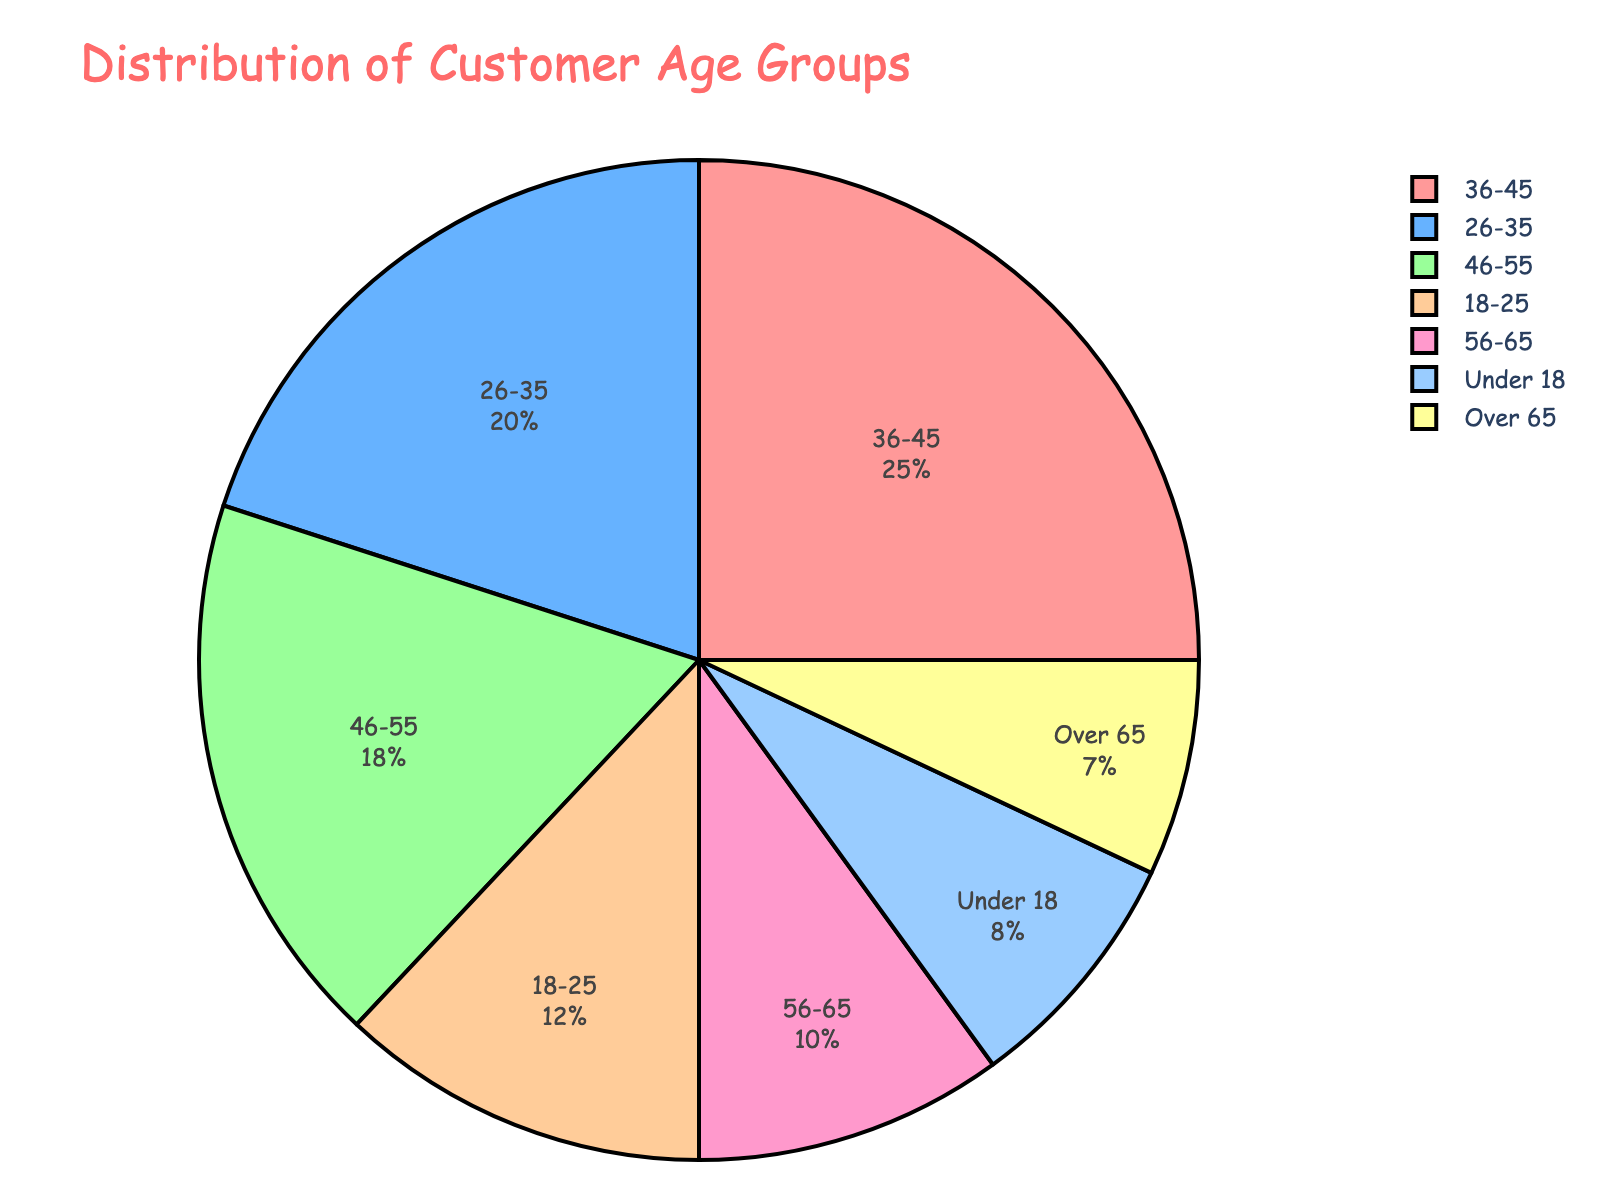What's the largest age group represented in the pie chart? The largest segment in the pie chart represents the age group 36-45 with the highest percentage.
Answer: 36-45 Which age group encompasses the smallest portion of customers? The smallest segment in the pie chart represents the age group Over 65 with the lowest percentage.
Answer: Over 65 What's the combined percentage of customers who are 35 years old or younger? To find the combined percentage, sum the percentages for the age groups Under 18, 18-25, and 26-35: 8% + 12% + 20% = 40%.
Answer: 40% Are there more customers under 18 years old or over 65 years old? Compare the percentages for the age groups Under 18 and Over 65: 8% for Under 18 and 7% for Over 65. Since 8% > 7%, there are more customers under 18 years old.
Answer: Under 18 Which two age groups contribute equally to the customer base according to the pie chart? Observing the pie chart, the age groups 18-25 and 56-65 both contribute equally with percentages of 12% and 10% respectively, which are not equal. Re-observe. There are no equal contributing groups visually.
Answer: None How much greater is the percentage of customers in the 36-45 age group compared to the 56-65 age group? Subtract the percentage of the 56-65 age group from the 36-45 age group: 25% - 10% = 15%.
Answer: 15% What is the visual representation of the age group 46-55, and how does it compare to the 18-25 age group? The pie chart shows that the segment for the age group 46-55 is larger than the segment for 18-25. The 46-55 age group has 18% while the 18-25 group has 12%.
Answer: 46-55 is larger Which age group appears in yellow? The age group labeled with the color yellow corresponds to the age group 56-65 as per the given custom color palette.
Answer: 56-65 